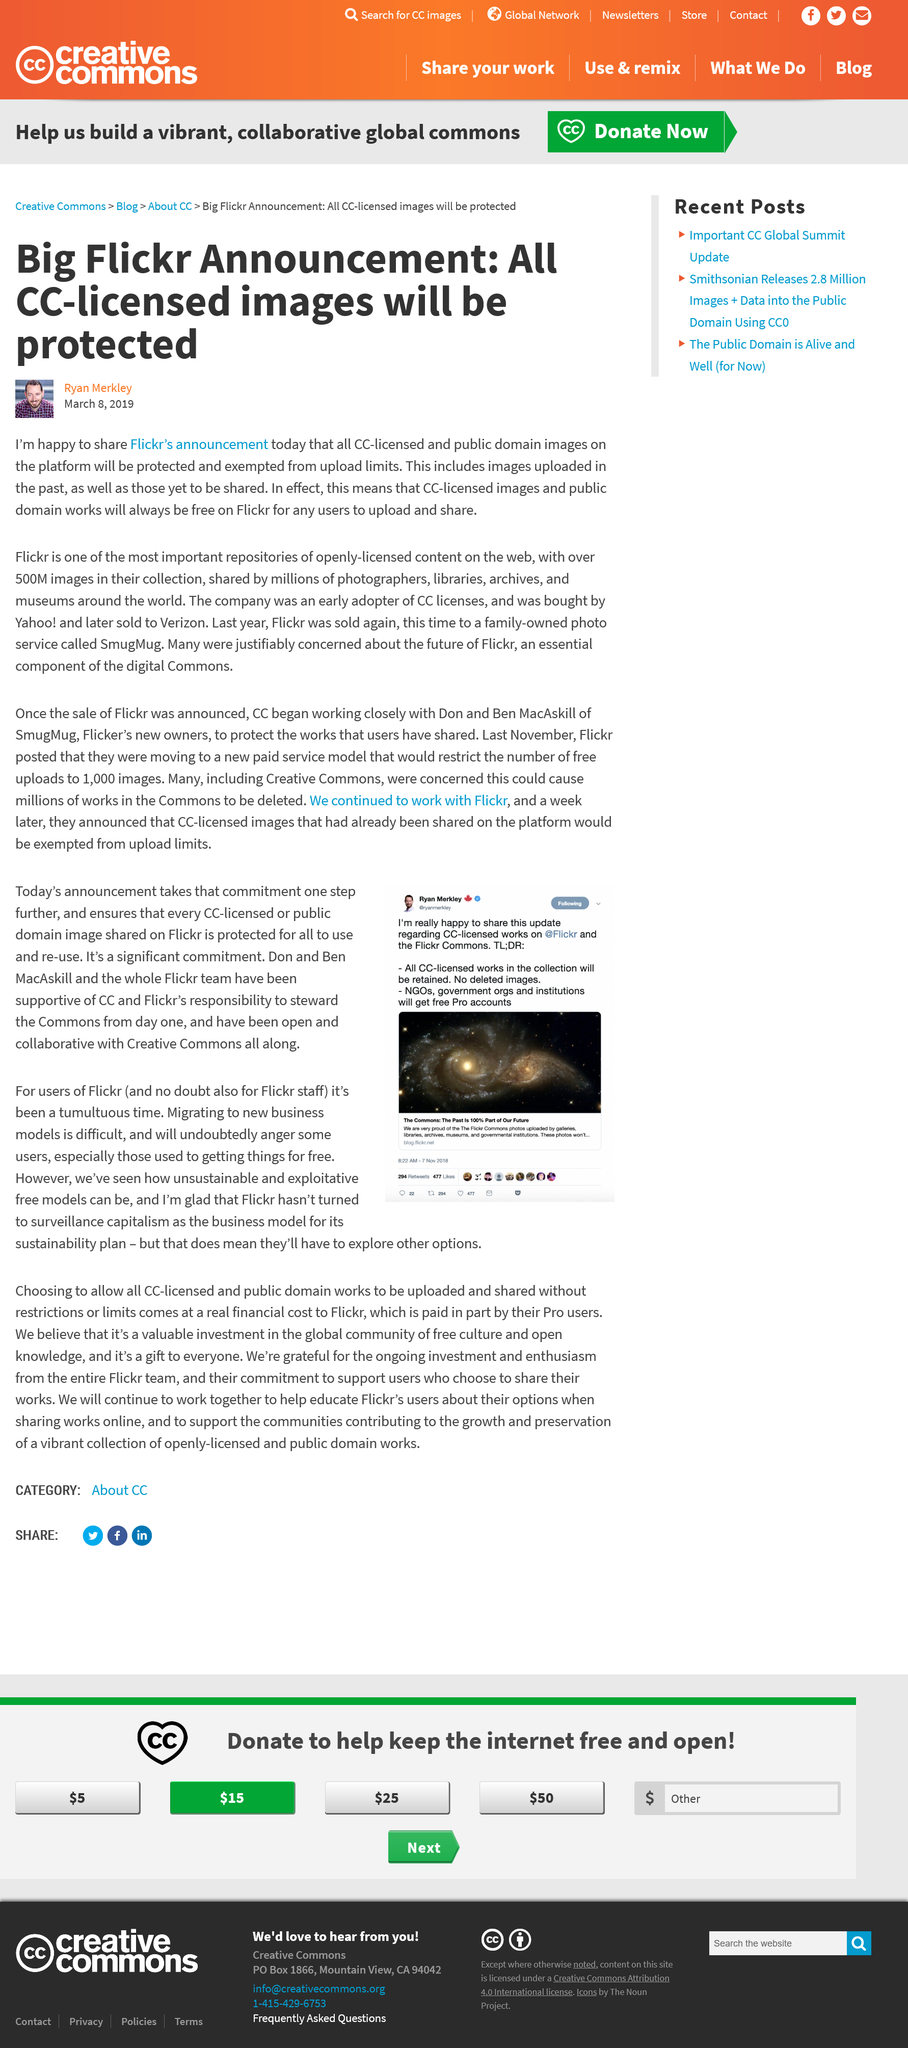Draw attention to some important aspects in this diagram. Flickr has over 500 million images in its collection. In 2020, the photo sharing platform Flickr was sold to a family-owned business called SmugMug, which specializes in photo hosting and sharing services. Flickr has announced that all images licensed under Creative Commons (CC) licenses or that are in the public domain will be protected and exempted from upload limits on their platform. 